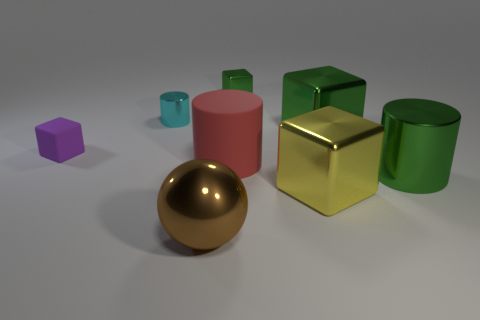The cylinder that is the same color as the tiny metallic cube is what size? The cylinder sharing the color with the tiny metallic cube, which is a golden hue, appears to be medium-sized when compared to the other objects in the image. 